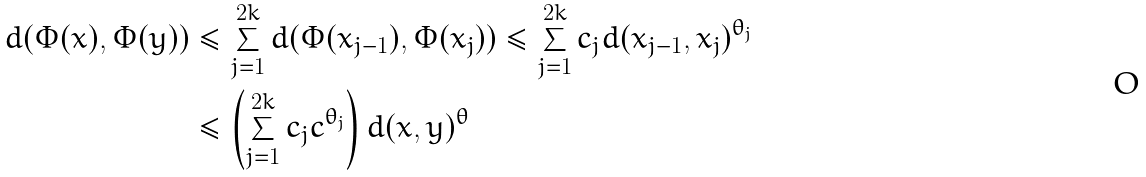<formula> <loc_0><loc_0><loc_500><loc_500>d ( \Phi ( x ) , \Phi ( y ) ) & \leq \sum _ { j = 1 } ^ { 2 k } d ( \Phi ( x _ { j - 1 } ) , \Phi ( x _ { j } ) ) \leq \sum _ { j = 1 } ^ { 2 k } c _ { j } d ( x _ { j - 1 } , x _ { j } ) ^ { \theta _ { j } } \\ & \leq \left ( \sum _ { j = 1 } ^ { 2 k } c _ { j } c ^ { \theta _ { j } } \right ) d ( x , y ) ^ { \theta }</formula> 